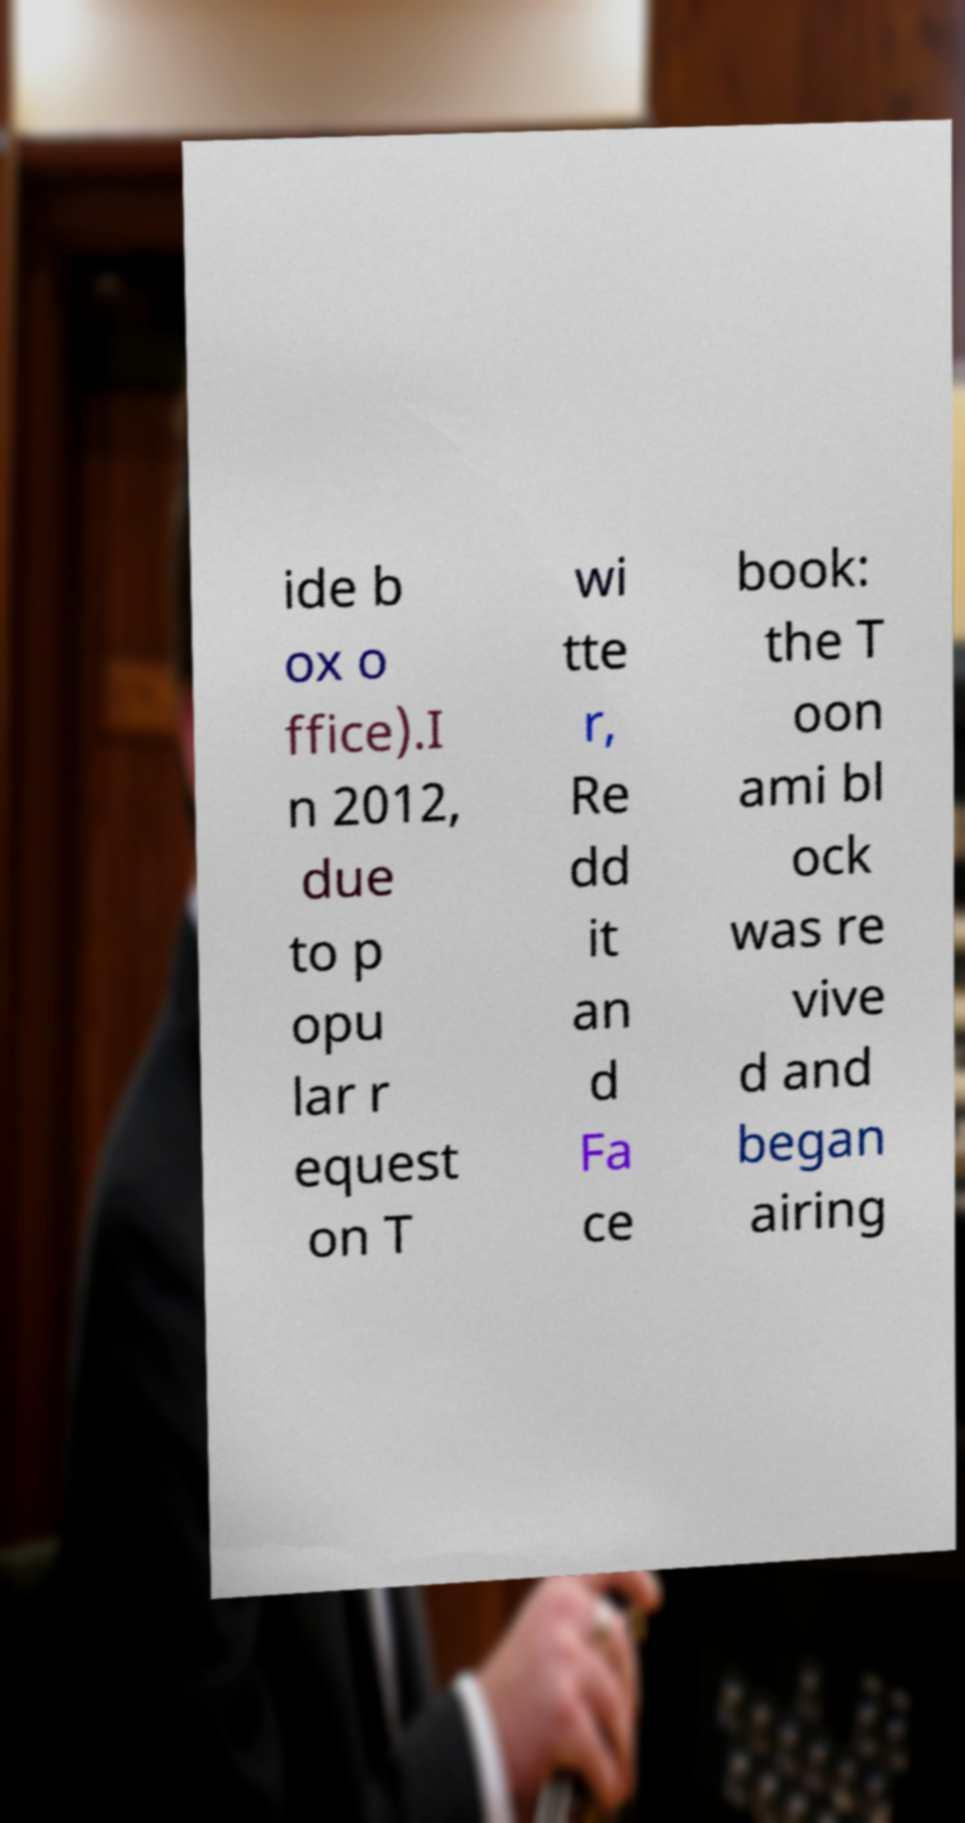Can you accurately transcribe the text from the provided image for me? ide b ox o ffice).I n 2012, due to p opu lar r equest on T wi tte r, Re dd it an d Fa ce book: the T oon ami bl ock was re vive d and began airing 